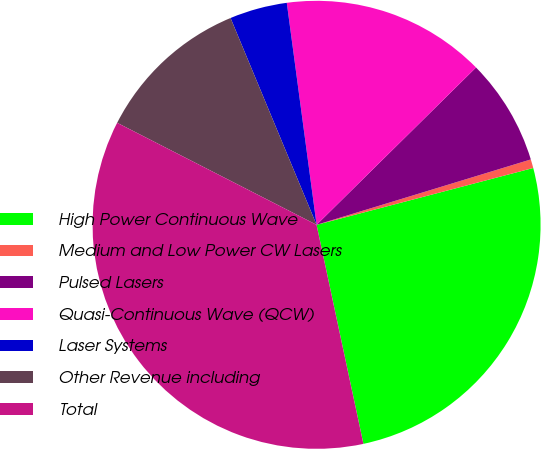Convert chart to OTSL. <chart><loc_0><loc_0><loc_500><loc_500><pie_chart><fcel>High Power Continuous Wave<fcel>Medium and Low Power CW Lasers<fcel>Pulsed Lasers<fcel>Quasi-Continuous Wave (QCW)<fcel>Laser Systems<fcel>Other Revenue including<fcel>Total<nl><fcel>25.73%<fcel>0.63%<fcel>7.68%<fcel>14.73%<fcel>4.15%<fcel>11.2%<fcel>35.88%<nl></chart> 